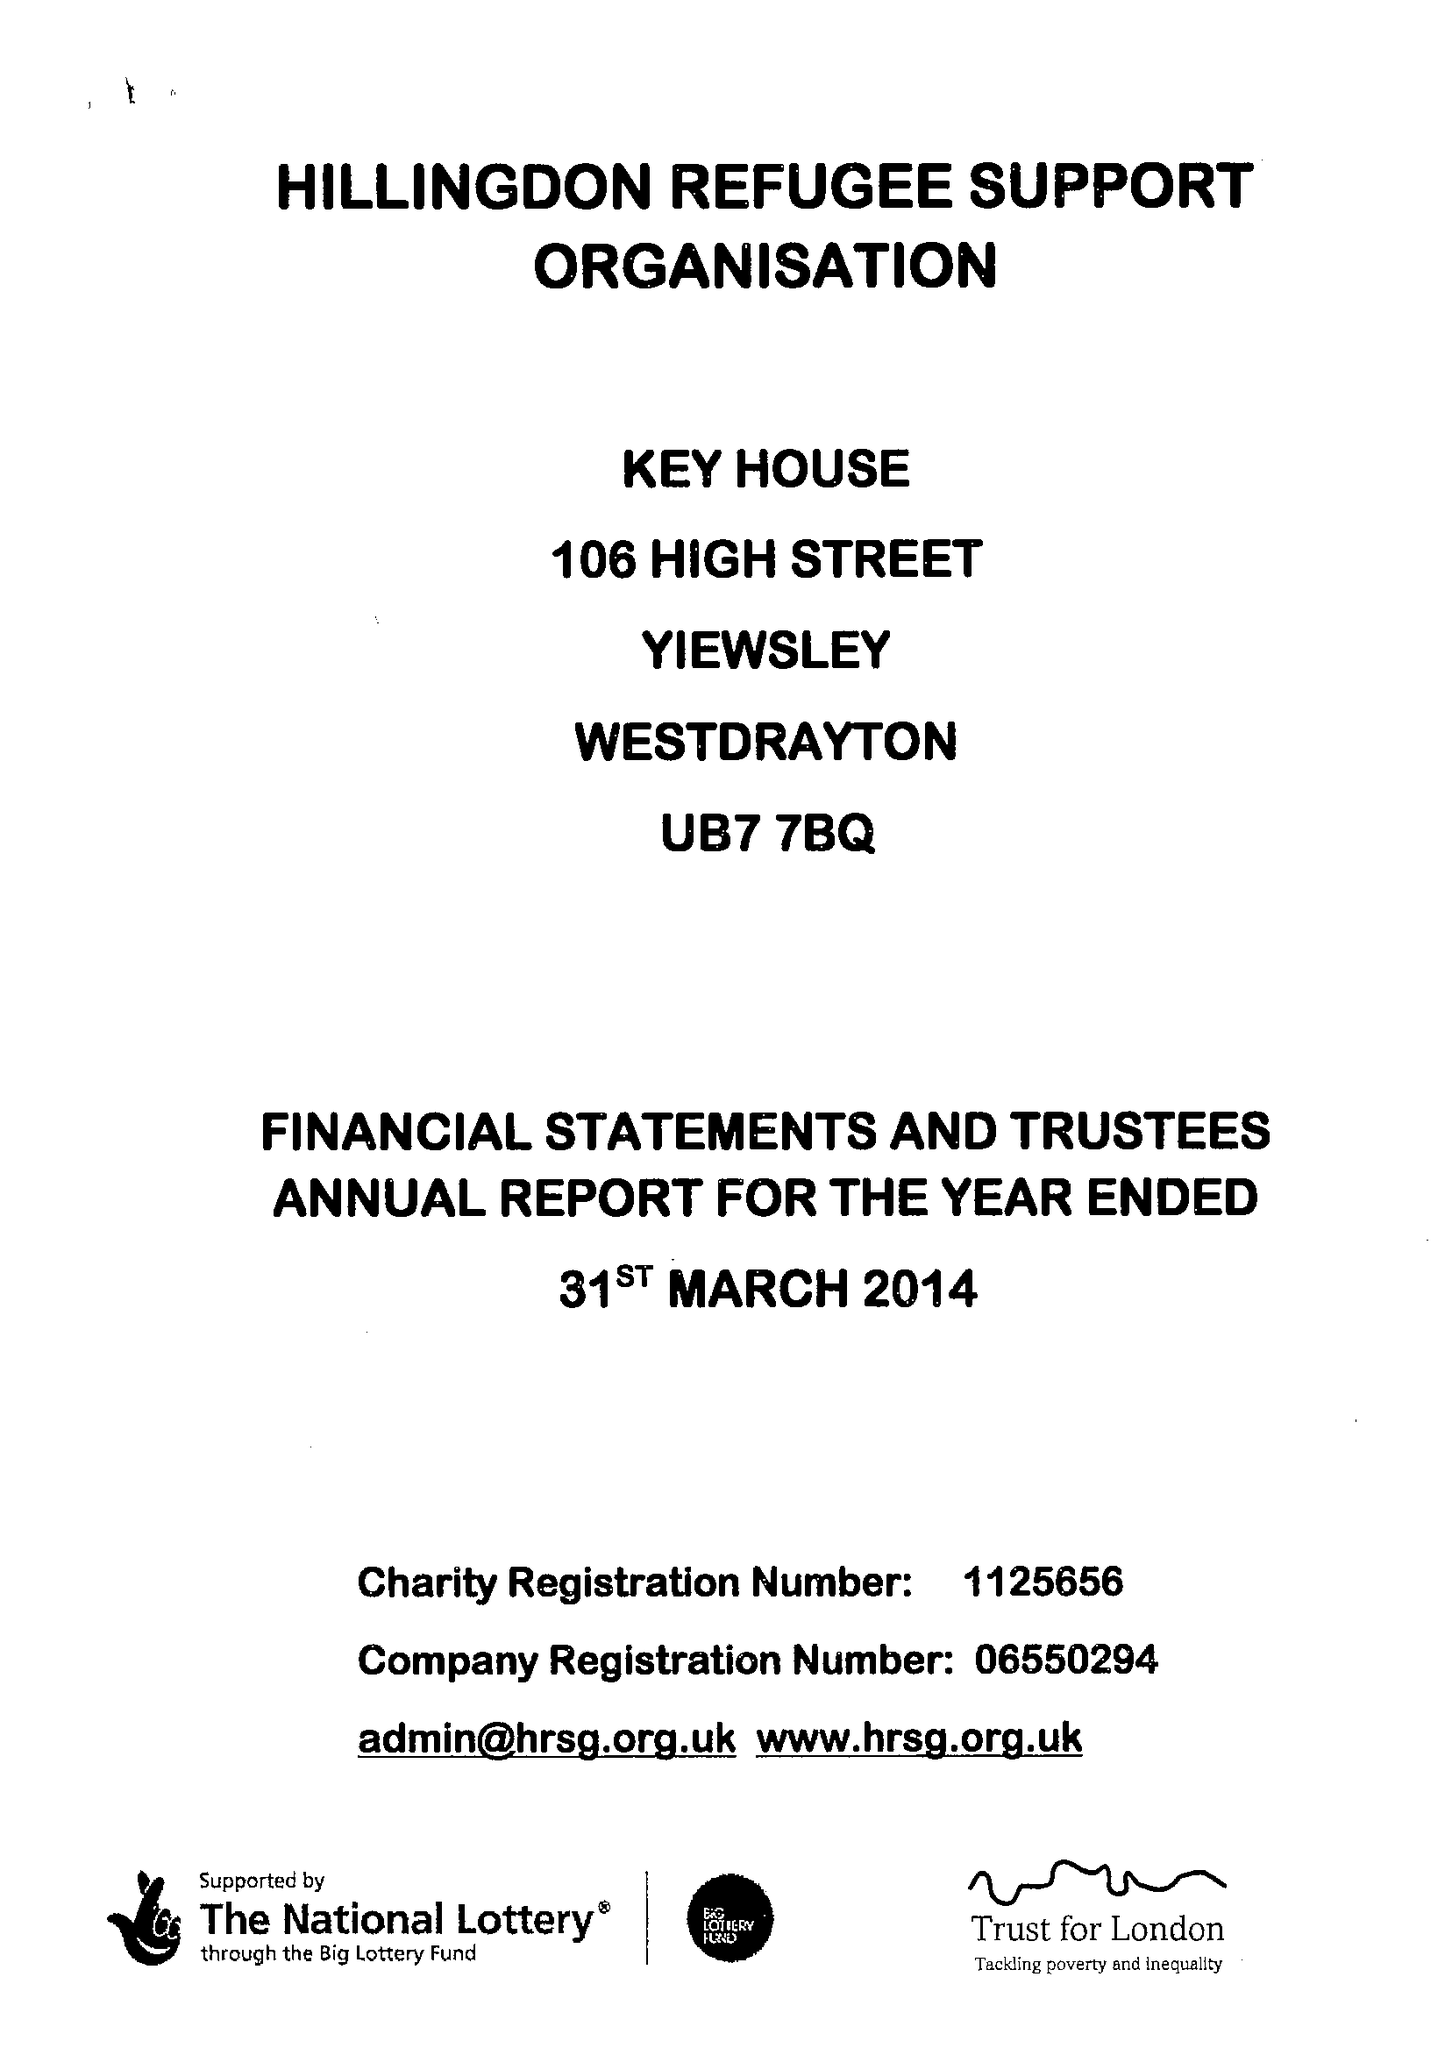What is the value for the charity_number?
Answer the question using a single word or phrase. 1125656 